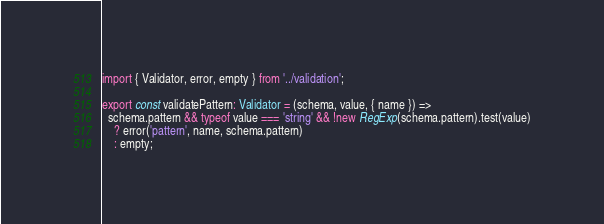Convert code to text. <code><loc_0><loc_0><loc_500><loc_500><_TypeScript_>import { Validator, error, empty } from '../validation';

export const validatePattern: Validator = (schema, value, { name }) =>
  schema.pattern && typeof value === 'string' && !new RegExp(schema.pattern).test(value)
    ? error('pattern', name, schema.pattern)
    : empty;
</code> 